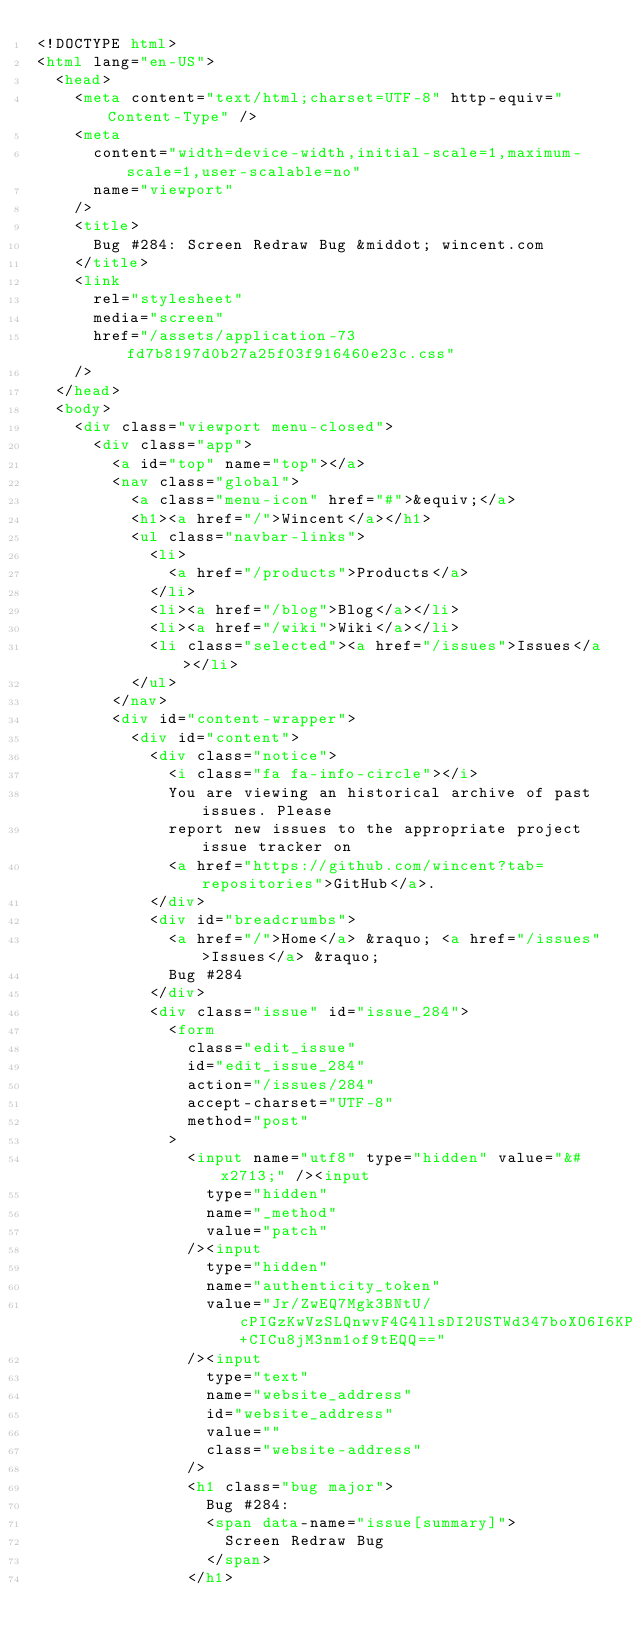Convert code to text. <code><loc_0><loc_0><loc_500><loc_500><_HTML_><!DOCTYPE html>
<html lang="en-US">
  <head>
    <meta content="text/html;charset=UTF-8" http-equiv="Content-Type" />
    <meta
      content="width=device-width,initial-scale=1,maximum-scale=1,user-scalable=no"
      name="viewport"
    />
    <title>
      Bug #284: Screen Redraw Bug &middot; wincent.com
    </title>
    <link
      rel="stylesheet"
      media="screen"
      href="/assets/application-73fd7b8197d0b27a25f03f916460e23c.css"
    />
  </head>
  <body>
    <div class="viewport menu-closed">
      <div class="app">
        <a id="top" name="top"></a>
        <nav class="global">
          <a class="menu-icon" href="#">&equiv;</a>
          <h1><a href="/">Wincent</a></h1>
          <ul class="navbar-links">
            <li>
              <a href="/products">Products</a>
            </li>
            <li><a href="/blog">Blog</a></li>
            <li><a href="/wiki">Wiki</a></li>
            <li class="selected"><a href="/issues">Issues</a></li>
          </ul>
        </nav>
        <div id="content-wrapper">
          <div id="content">
            <div class="notice">
              <i class="fa fa-info-circle"></i>
              You are viewing an historical archive of past issues. Please
              report new issues to the appropriate project issue tracker on
              <a href="https://github.com/wincent?tab=repositories">GitHub</a>.
            </div>
            <div id="breadcrumbs">
              <a href="/">Home</a> &raquo; <a href="/issues">Issues</a> &raquo;
              Bug #284
            </div>
            <div class="issue" id="issue_284">
              <form
                class="edit_issue"
                id="edit_issue_284"
                action="/issues/284"
                accept-charset="UTF-8"
                method="post"
              >
                <input name="utf8" type="hidden" value="&#x2713;" /><input
                  type="hidden"
                  name="_method"
                  value="patch"
                /><input
                  type="hidden"
                  name="authenticity_token"
                  value="Jr/ZwEQ7Mgk3BNtU/cPIGzKwVzSLQnwvF4G4llsDI2USTWd347boXO6I6KPM6puvhzI+CICu8jM3nm1of9tEQQ=="
                /><input
                  type="text"
                  name="website_address"
                  id="website_address"
                  value=""
                  class="website-address"
                />
                <h1 class="bug major">
                  Bug #284:
                  <span data-name="issue[summary]">
                    Screen Redraw Bug
                  </span>
                </h1></code> 